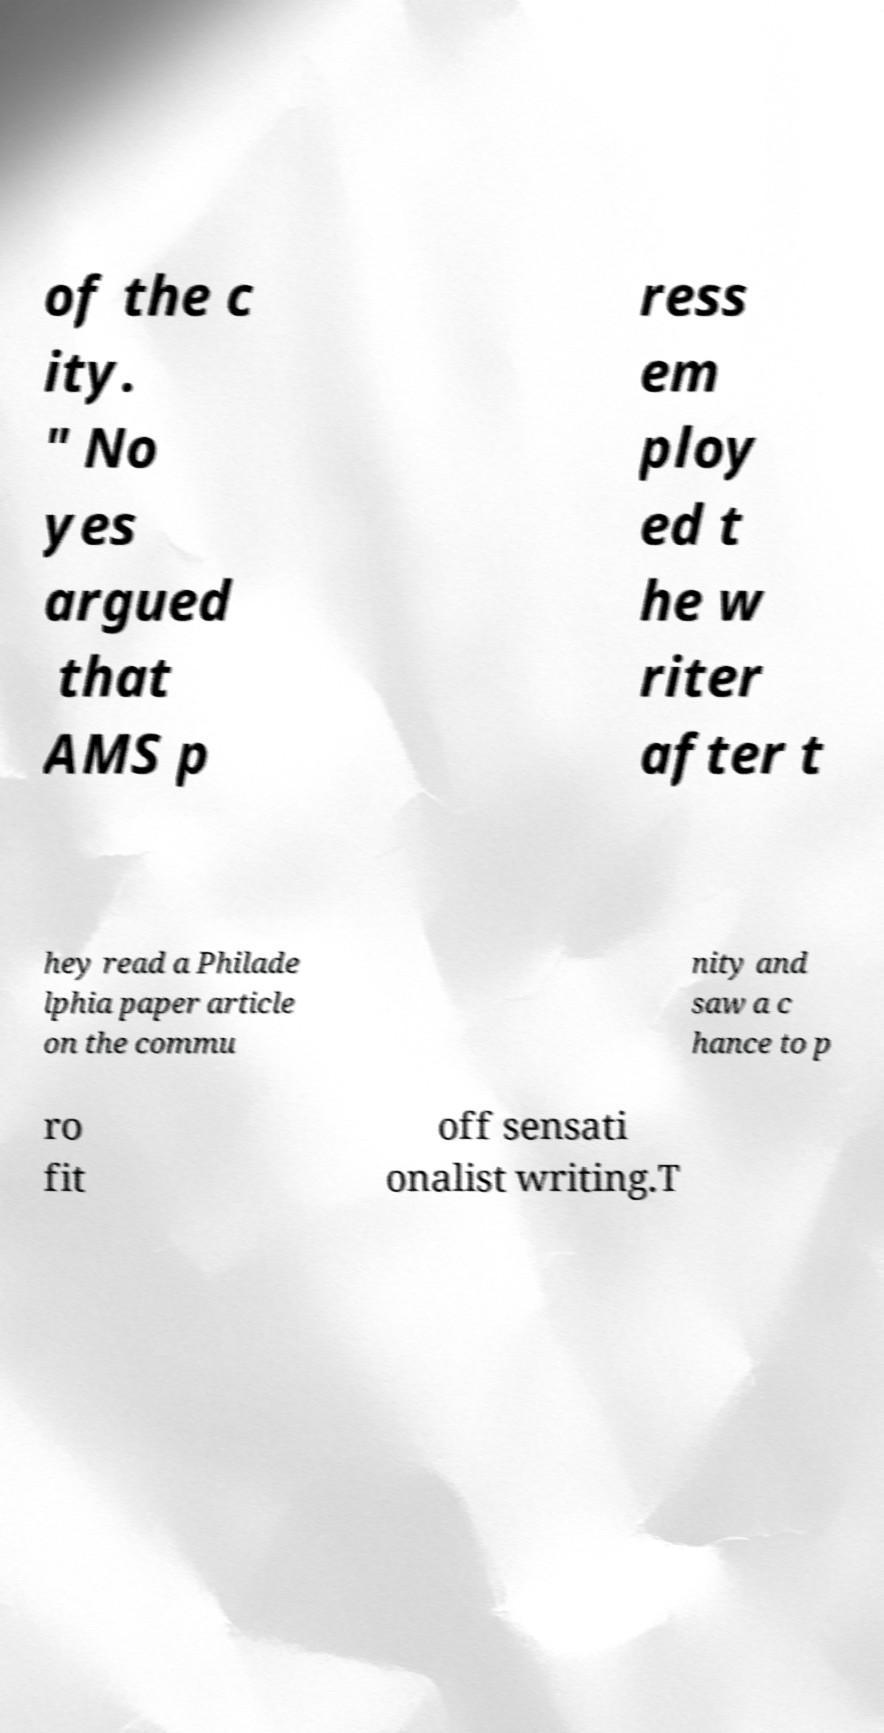Can you accurately transcribe the text from the provided image for me? of the c ity. " No yes argued that AMS p ress em ploy ed t he w riter after t hey read a Philade lphia paper article on the commu nity and saw a c hance to p ro fit off sensati onalist writing.T 